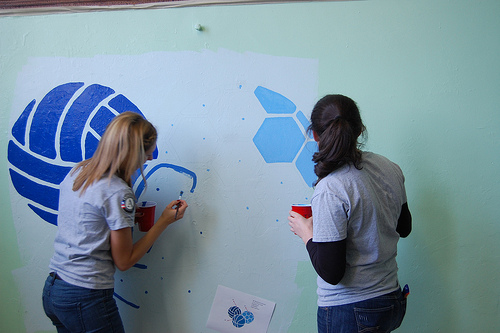<image>
Is the paint on the wall? Yes. Looking at the image, I can see the paint is positioned on top of the wall, with the wall providing support. Is the painting in front of the girl? No. The painting is not in front of the girl. The spatial positioning shows a different relationship between these objects. 